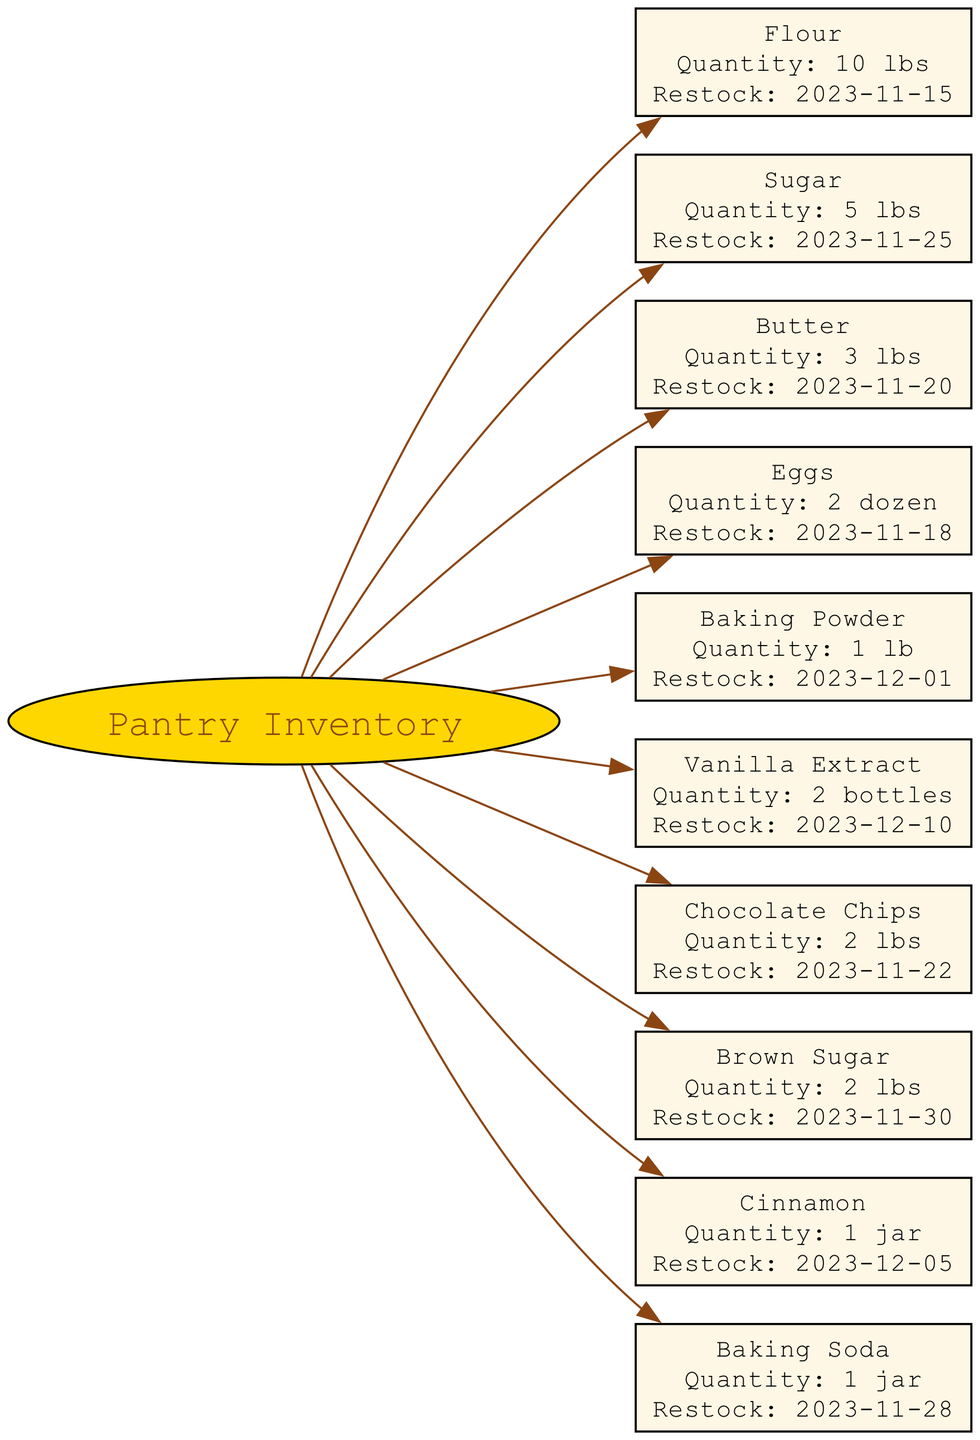What is the quantity of Flour in the pantry? The diagram directly lists the quantity of Flour as "10 lbs".
Answer: 10 lbs When is the next restock date for Sugar? The restock date for Sugar is provided as "2023-11-25" in the diagram.
Answer: 2023-11-25 How many items are listed in the pantry inventory? The diagram contains ten items, as there are ten distinct nodes representing each ingredient in the pantry.
Answer: 10 What is the quantity of Baking Powder? The diagram shows that the quantity of Baking Powder is "1 lb".
Answer: 1 lb Which item has a restock date on December 10? The diagram specifies that Vanilla Extract has a restock date of "2023-12-10".
Answer: Vanilla Extract Which item has the smallest quantity in the pantry? By reviewing the quantities, Butter (3 lbs) and Baking Powder (1 lb) are the smallest, but Baking Powder has the least at "1 lb".
Answer: Baking Powder What is the restock date for the item with 2 dozen? The item with 2 dozen is Eggs, and according to the diagram, the restock date is "2023-11-18".
Answer: 2023-11-18 What items need to be restocked before the end of November? Looking at the restock dates, Sugar (2023-11-25), Chocolate Chips (2023-11-22), Eggs (2023-11-18), and Baking Soda (2023-11-28) all need restocking before December.
Answer: Sugar, Chocolate Chips, Eggs, Baking Soda Which item requires restocking first among the items listed? By comparing the restock dates, Eggs with a date of "2023-11-18" is the first item that requires restocking among all listed items.
Answer: Eggs 